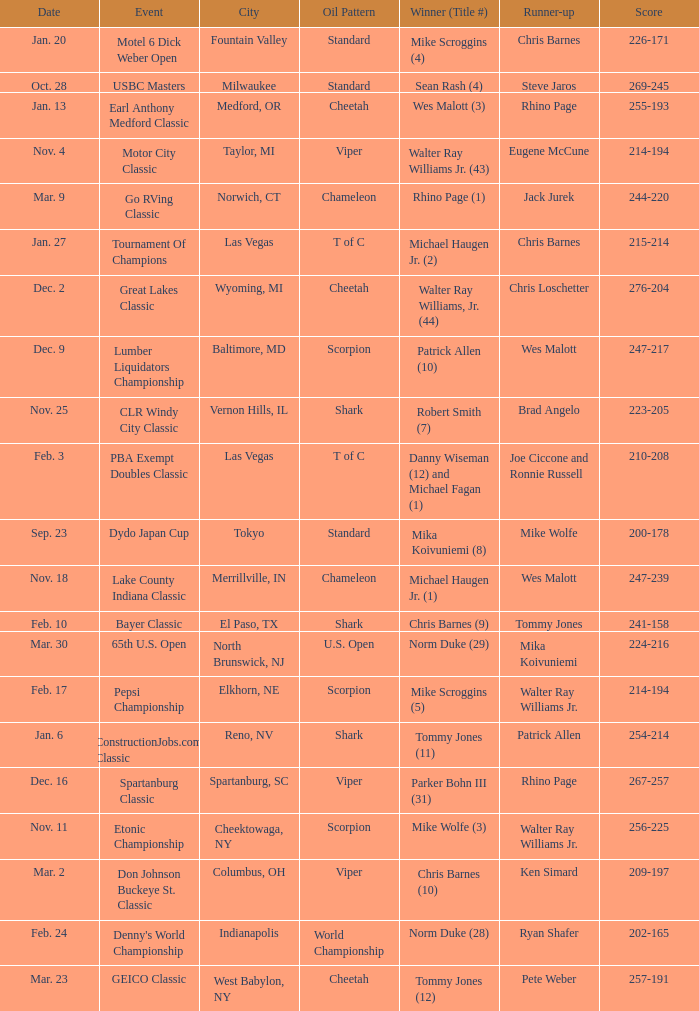When is the lake county indiana classic event held with a chameleon oil pattern? Nov. 18. 